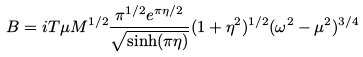Convert formula to latex. <formula><loc_0><loc_0><loc_500><loc_500>B = i T \mu M ^ { 1 / 2 } \frac { \pi ^ { 1 / 2 } e ^ { \pi \eta / 2 } } { \sqrt { \sinh ( \pi \eta ) } } ( 1 + \eta ^ { 2 } ) ^ { 1 / 2 } ( \omega ^ { 2 } - \mu ^ { 2 } ) ^ { 3 / 4 }</formula> 